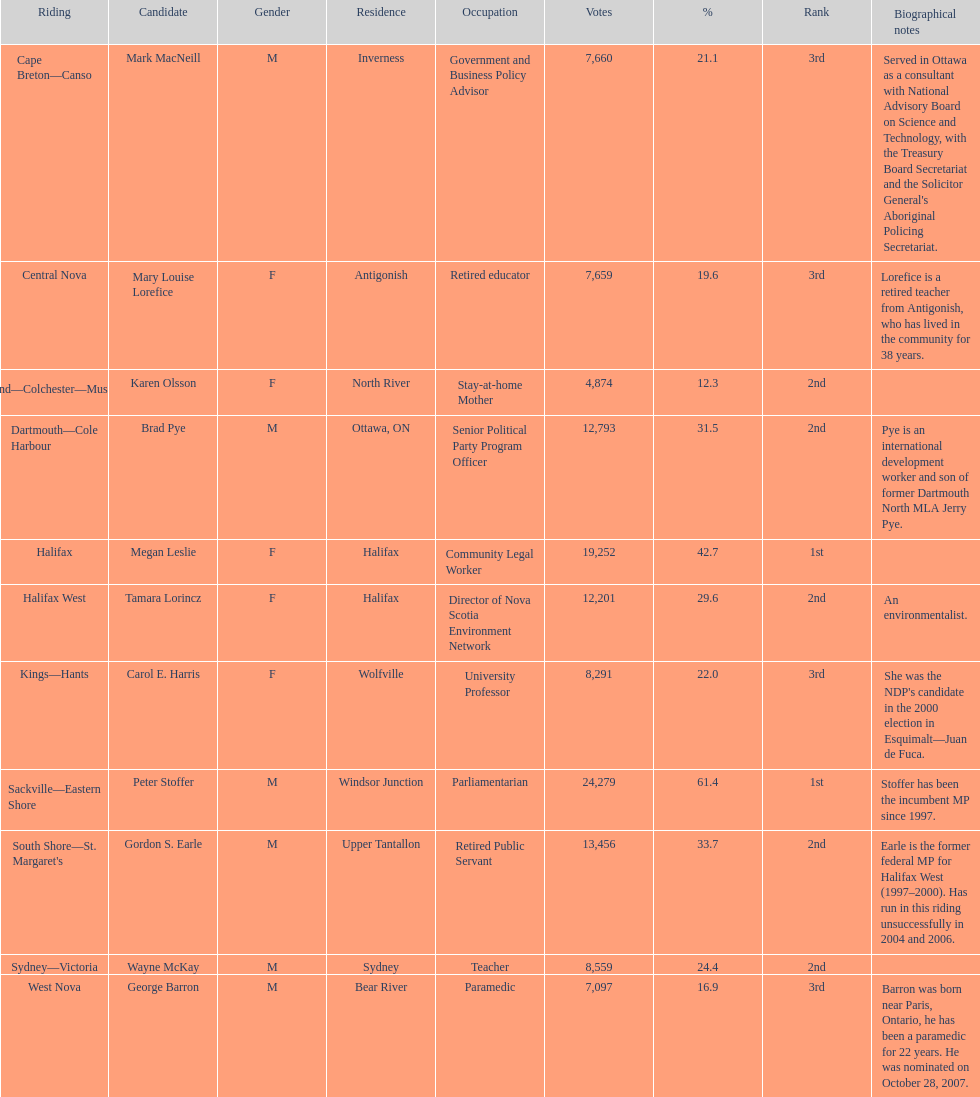How many contenders received a higher number of votes than tamara lorincz? 4. 